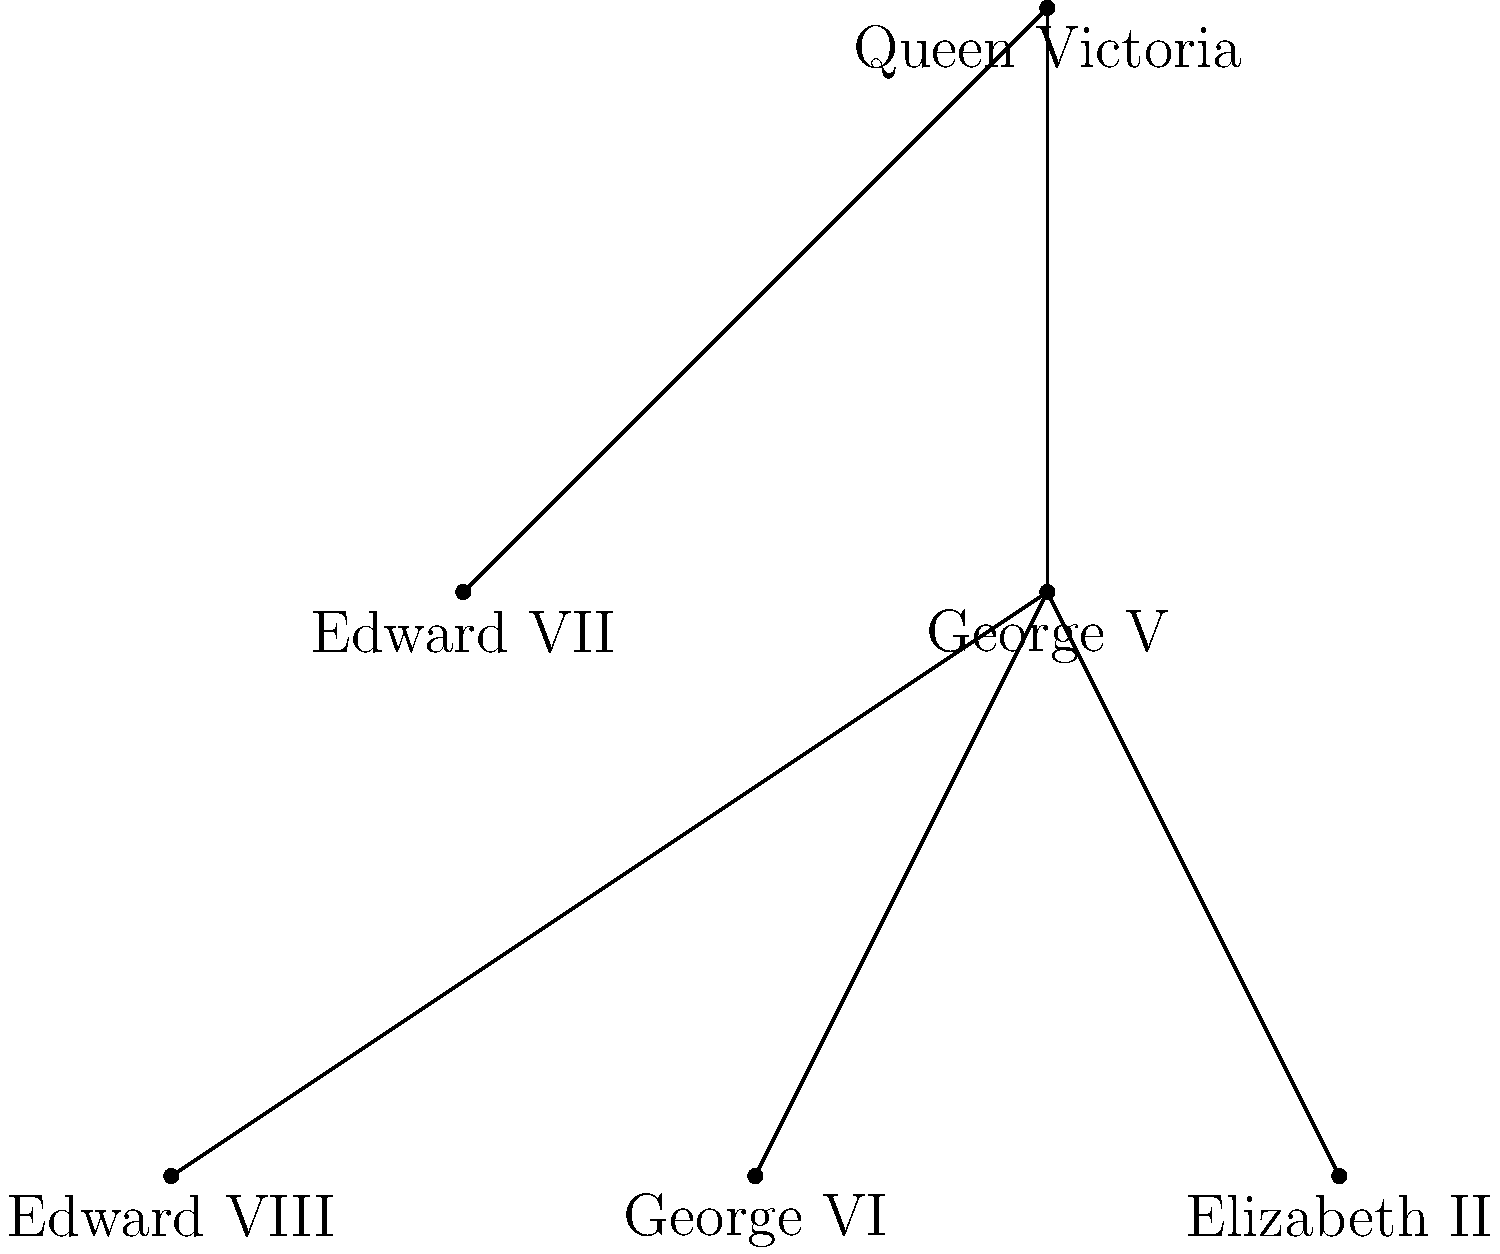Based on the family tree of British monarchs shown, which ruler abdicated the throne, leading to a significant change in the line of succession? To answer this question, let's analyze the family tree step-by-step:

1. The tree starts with Queen Victoria at the top.
2. We can see that Victoria had two children shown: Edward VII and George V.
3. George V had three children: Edward VIII, George VI, and Elizabeth II.
4. Normally, the line of succession would follow the firstborn child.
5. However, we know from history that there was a significant change in the line of succession during this period.
6. Edward VIII, the eldest son of George V, became king after his father's death.
7. But Edward VIII abdicated the throne less than a year into his reign in 1936.
8. This abdication led to his younger brother, George VI, becoming king.
9. George VI's reign was then followed by his daughter, Elizabeth II.

The abdication of Edward VIII was a pivotal moment in British royal history, as it unexpectedly changed the line of succession and ultimately led to Elizabeth II becoming queen.
Answer: Edward VIII 